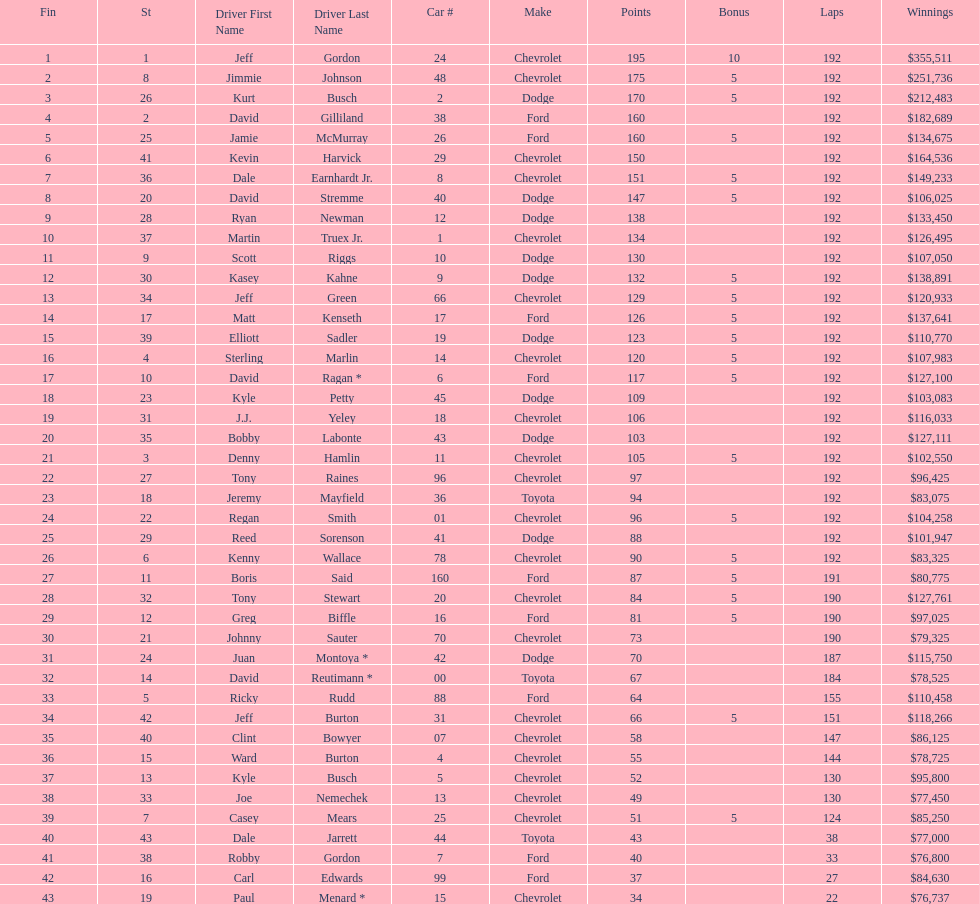What driver earned the least amount of winnings? Paul Menard *. 